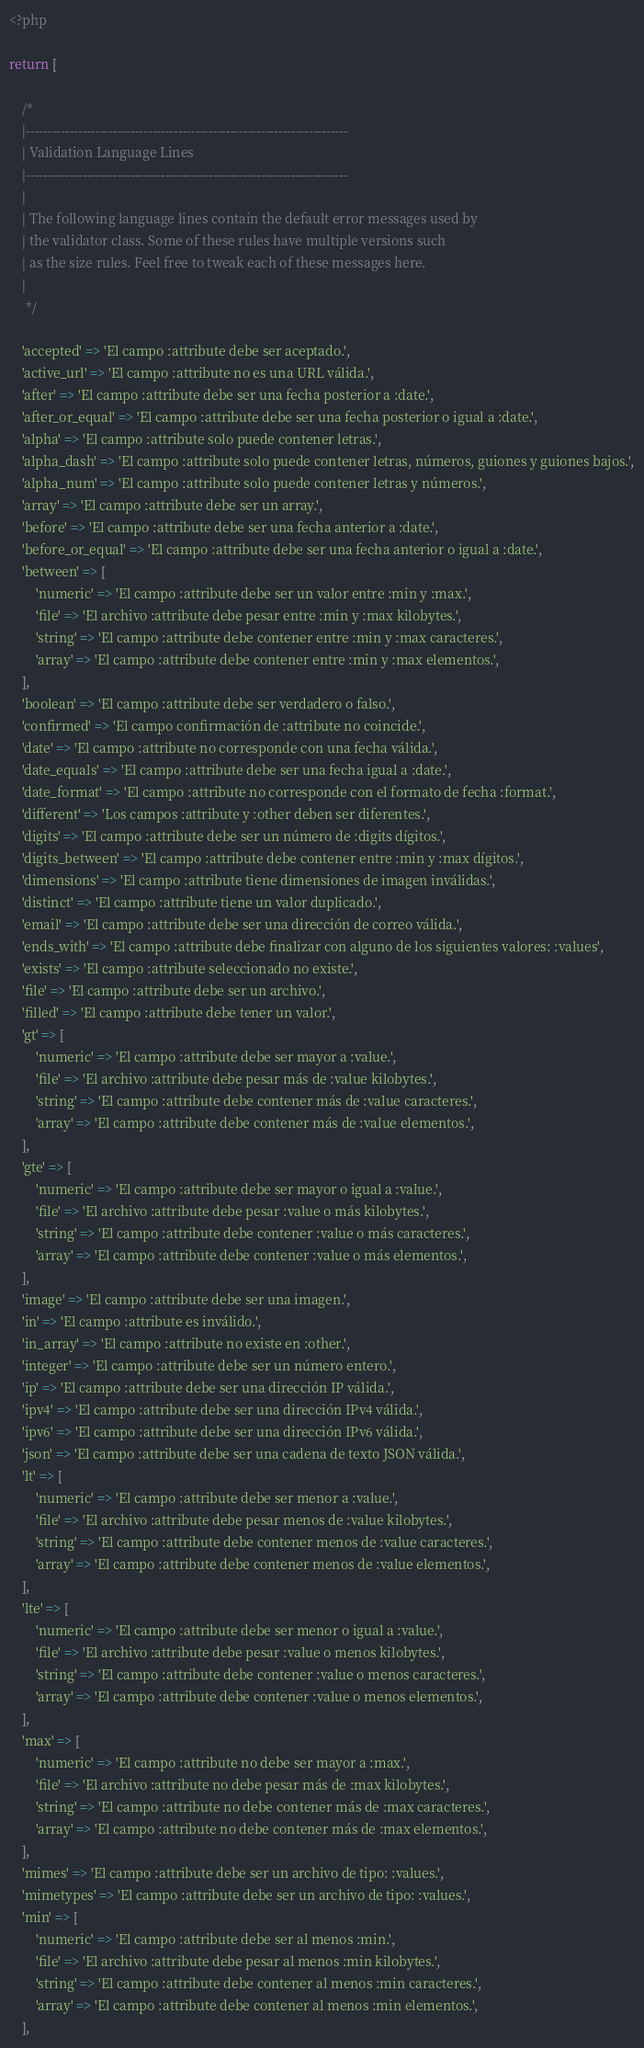<code> <loc_0><loc_0><loc_500><loc_500><_PHP_><?php

return [

    /*
    |--------------------------------------------------------------------------
    | Validation Language Lines
    |--------------------------------------------------------------------------
    |
    | The following language lines contain the default error messages used by
    | the validator class. Some of these rules have multiple versions such
    | as the size rules. Feel free to tweak each of these messages here.
    |
     */

    'accepted' => 'El campo :attribute debe ser aceptado.',
    'active_url' => 'El campo :attribute no es una URL válida.',
    'after' => 'El campo :attribute debe ser una fecha posterior a :date.',
    'after_or_equal' => 'El campo :attribute debe ser una fecha posterior o igual a :date.',
    'alpha' => 'El campo :attribute solo puede contener letras.',
    'alpha_dash' => 'El campo :attribute solo puede contener letras, números, guiones y guiones bajos.',
    'alpha_num' => 'El campo :attribute solo puede contener letras y números.',
    'array' => 'El campo :attribute debe ser un array.',
    'before' => 'El campo :attribute debe ser una fecha anterior a :date.',
    'before_or_equal' => 'El campo :attribute debe ser una fecha anterior o igual a :date.',
    'between' => [
        'numeric' => 'El campo :attribute debe ser un valor entre :min y :max.',
        'file' => 'El archivo :attribute debe pesar entre :min y :max kilobytes.',
        'string' => 'El campo :attribute debe contener entre :min y :max caracteres.',
        'array' => 'El campo :attribute debe contener entre :min y :max elementos.',
    ],
    'boolean' => 'El campo :attribute debe ser verdadero o falso.',
    'confirmed' => 'El campo confirmación de :attribute no coincide.',
    'date' => 'El campo :attribute no corresponde con una fecha válida.',
    'date_equals' => 'El campo :attribute debe ser una fecha igual a :date.',
    'date_format' => 'El campo :attribute no corresponde con el formato de fecha :format.',
    'different' => 'Los campos :attribute y :other deben ser diferentes.',
    'digits' => 'El campo :attribute debe ser un número de :digits dígitos.',
    'digits_between' => 'El campo :attribute debe contener entre :min y :max dígitos.',
    'dimensions' => 'El campo :attribute tiene dimensiones de imagen inválidas.',
    'distinct' => 'El campo :attribute tiene un valor duplicado.',
    'email' => 'El campo :attribute debe ser una dirección de correo válida.',
    'ends_with' => 'El campo :attribute debe finalizar con alguno de los siguientes valores: :values',
    'exists' => 'El campo :attribute seleccionado no existe.',
    'file' => 'El campo :attribute debe ser un archivo.',
    'filled' => 'El campo :attribute debe tener un valor.',
    'gt' => [
        'numeric' => 'El campo :attribute debe ser mayor a :value.',
        'file' => 'El archivo :attribute debe pesar más de :value kilobytes.',
        'string' => 'El campo :attribute debe contener más de :value caracteres.',
        'array' => 'El campo :attribute debe contener más de :value elementos.',
    ],
    'gte' => [
        'numeric' => 'El campo :attribute debe ser mayor o igual a :value.',
        'file' => 'El archivo :attribute debe pesar :value o más kilobytes.',
        'string' => 'El campo :attribute debe contener :value o más caracteres.',
        'array' => 'El campo :attribute debe contener :value o más elementos.',
    ],
    'image' => 'El campo :attribute debe ser una imagen.',
    'in' => 'El campo :attribute es inválido.',
    'in_array' => 'El campo :attribute no existe en :other.',
    'integer' => 'El campo :attribute debe ser un número entero.',
    'ip' => 'El campo :attribute debe ser una dirección IP válida.',
    'ipv4' => 'El campo :attribute debe ser una dirección IPv4 válida.',
    'ipv6' => 'El campo :attribute debe ser una dirección IPv6 válida.',
    'json' => 'El campo :attribute debe ser una cadena de texto JSON válida.',
    'lt' => [
        'numeric' => 'El campo :attribute debe ser menor a :value.',
        'file' => 'El archivo :attribute debe pesar menos de :value kilobytes.',
        'string' => 'El campo :attribute debe contener menos de :value caracteres.',
        'array' => 'El campo :attribute debe contener menos de :value elementos.',
    ],
    'lte' => [
        'numeric' => 'El campo :attribute debe ser menor o igual a :value.',
        'file' => 'El archivo :attribute debe pesar :value o menos kilobytes.',
        'string' => 'El campo :attribute debe contener :value o menos caracteres.',
        'array' => 'El campo :attribute debe contener :value o menos elementos.',
    ],
    'max' => [
        'numeric' => 'El campo :attribute no debe ser mayor a :max.',
        'file' => 'El archivo :attribute no debe pesar más de :max kilobytes.',
        'string' => 'El campo :attribute no debe contener más de :max caracteres.',
        'array' => 'El campo :attribute no debe contener más de :max elementos.',
    ],
    'mimes' => 'El campo :attribute debe ser un archivo de tipo: :values.',
    'mimetypes' => 'El campo :attribute debe ser un archivo de tipo: :values.',
    'min' => [
        'numeric' => 'El campo :attribute debe ser al menos :min.',
        'file' => 'El archivo :attribute debe pesar al menos :min kilobytes.',
        'string' => 'El campo :attribute debe contener al menos :min caracteres.',
        'array' => 'El campo :attribute debe contener al menos :min elementos.',
    ],</code> 